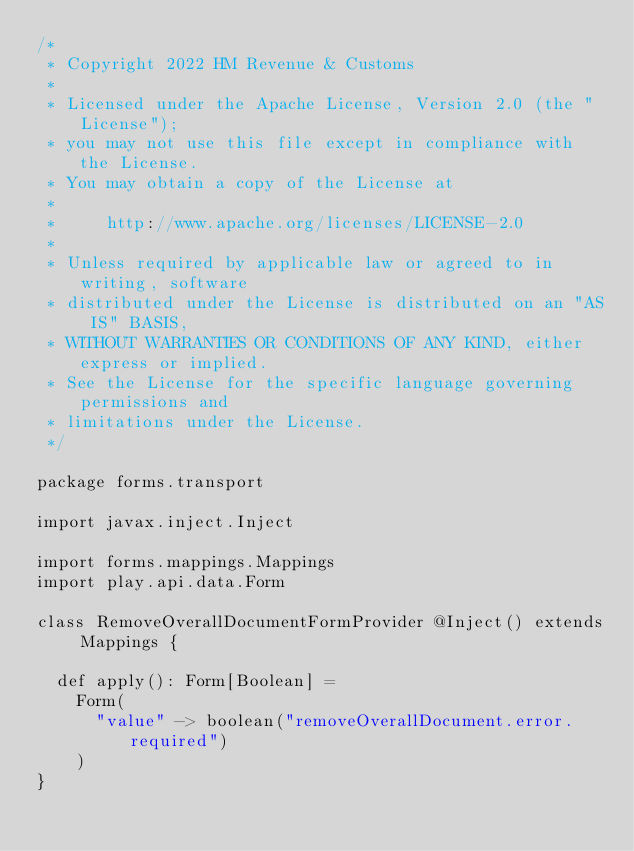<code> <loc_0><loc_0><loc_500><loc_500><_Scala_>/*
 * Copyright 2022 HM Revenue & Customs
 *
 * Licensed under the Apache License, Version 2.0 (the "License");
 * you may not use this file except in compliance with the License.
 * You may obtain a copy of the License at
 *
 *     http://www.apache.org/licenses/LICENSE-2.0
 *
 * Unless required by applicable law or agreed to in writing, software
 * distributed under the License is distributed on an "AS IS" BASIS,
 * WITHOUT WARRANTIES OR CONDITIONS OF ANY KIND, either express or implied.
 * See the License for the specific language governing permissions and
 * limitations under the License.
 */

package forms.transport

import javax.inject.Inject

import forms.mappings.Mappings
import play.api.data.Form

class RemoveOverallDocumentFormProvider @Inject() extends Mappings {

  def apply(): Form[Boolean] =
    Form(
      "value" -> boolean("removeOverallDocument.error.required")
    )
}
</code> 